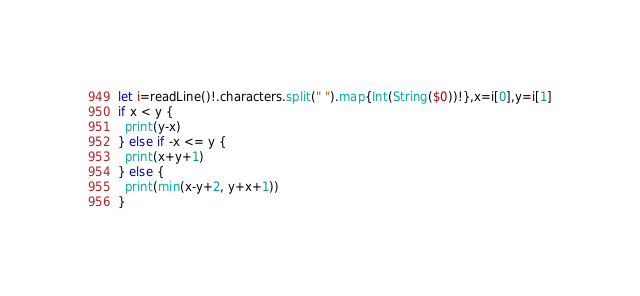Convert code to text. <code><loc_0><loc_0><loc_500><loc_500><_Swift_>let i=readLine()!.characters.split(" ").map{Int(String($0))!},x=i[0],y=i[1]
if x < y {
  print(y-x)
} else if -x <= y {
  print(x+y+1)
} else {
  print(min(x-y+2, y+x+1))
}</code> 